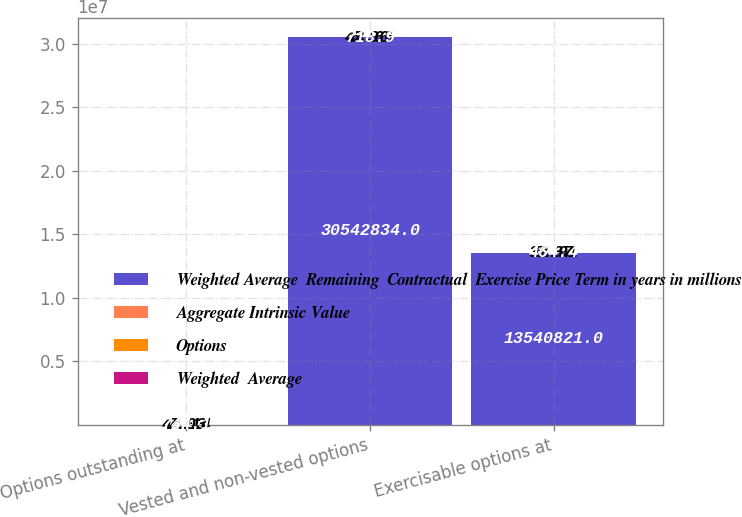Convert chart to OTSL. <chart><loc_0><loc_0><loc_500><loc_500><stacked_bar_chart><ecel><fcel>Options outstanding at<fcel>Vested and non-vested options<fcel>Exercisable options at<nl><fcel>Weighted Average  Remaining  Contractual  Exercise Price Term in years in millions<fcel>44.14<fcel>3.05428e+07<fcel>1.35408e+07<nl><fcel>Aggregate Intrinsic Value<fcel>44.14<fcel>43.66<fcel>32.91<nl><fcel>Options<fcel>7.03<fcel>6.96<fcel>5.37<nl><fcel>Weighted  Average<fcel>744.1<fcel>718.9<fcel>464.4<nl></chart> 